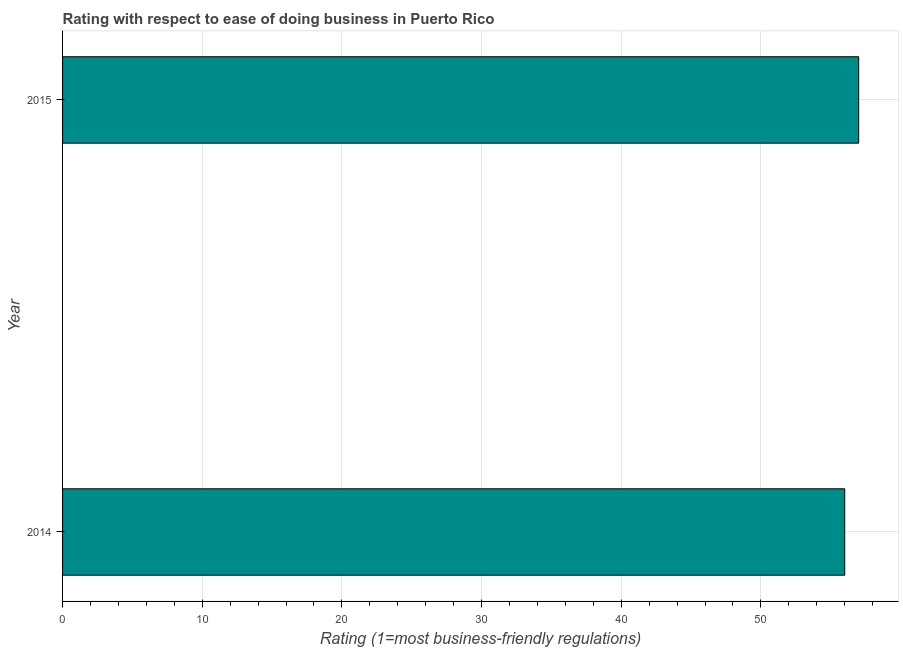What is the title of the graph?
Ensure brevity in your answer.  Rating with respect to ease of doing business in Puerto Rico. What is the label or title of the X-axis?
Ensure brevity in your answer.  Rating (1=most business-friendly regulations). In which year was the ease of doing business index maximum?
Provide a succinct answer. 2015. What is the sum of the ease of doing business index?
Keep it short and to the point. 113. What is the difference between the ease of doing business index in 2014 and 2015?
Your response must be concise. -1. What is the average ease of doing business index per year?
Ensure brevity in your answer.  56. What is the median ease of doing business index?
Provide a succinct answer. 56.5. Do a majority of the years between 2015 and 2014 (inclusive) have ease of doing business index greater than 8 ?
Make the answer very short. No. Are all the bars in the graph horizontal?
Your answer should be compact. Yes. How many years are there in the graph?
Provide a succinct answer. 2. What is the Rating (1=most business-friendly regulations) of 2014?
Ensure brevity in your answer.  56. What is the difference between the Rating (1=most business-friendly regulations) in 2014 and 2015?
Your response must be concise. -1. 